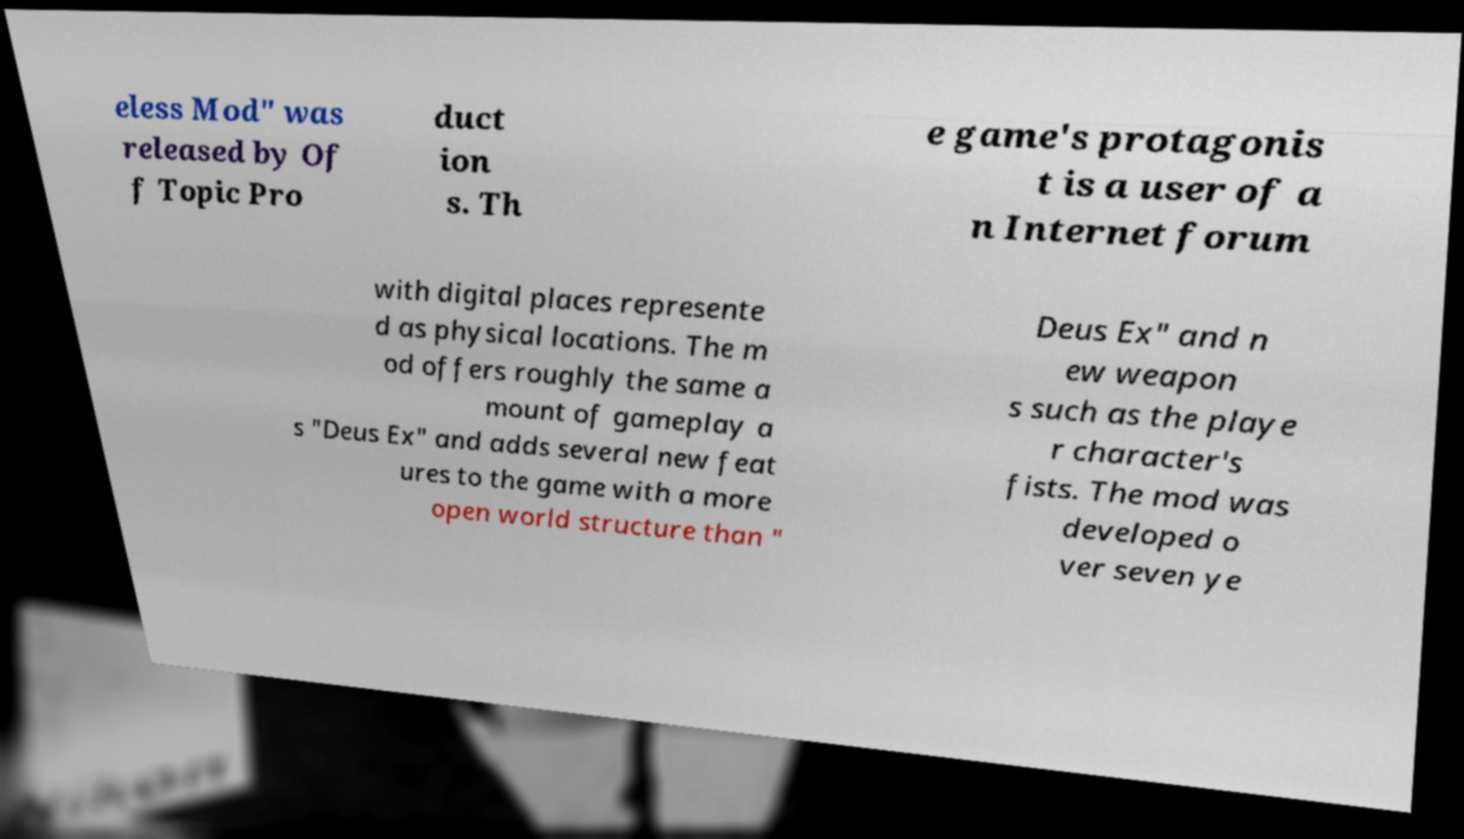What messages or text are displayed in this image? I need them in a readable, typed format. eless Mod" was released by Of f Topic Pro duct ion s. Th e game's protagonis t is a user of a n Internet forum with digital places represente d as physical locations. The m od offers roughly the same a mount of gameplay a s "Deus Ex" and adds several new feat ures to the game with a more open world structure than " Deus Ex" and n ew weapon s such as the playe r character's fists. The mod was developed o ver seven ye 